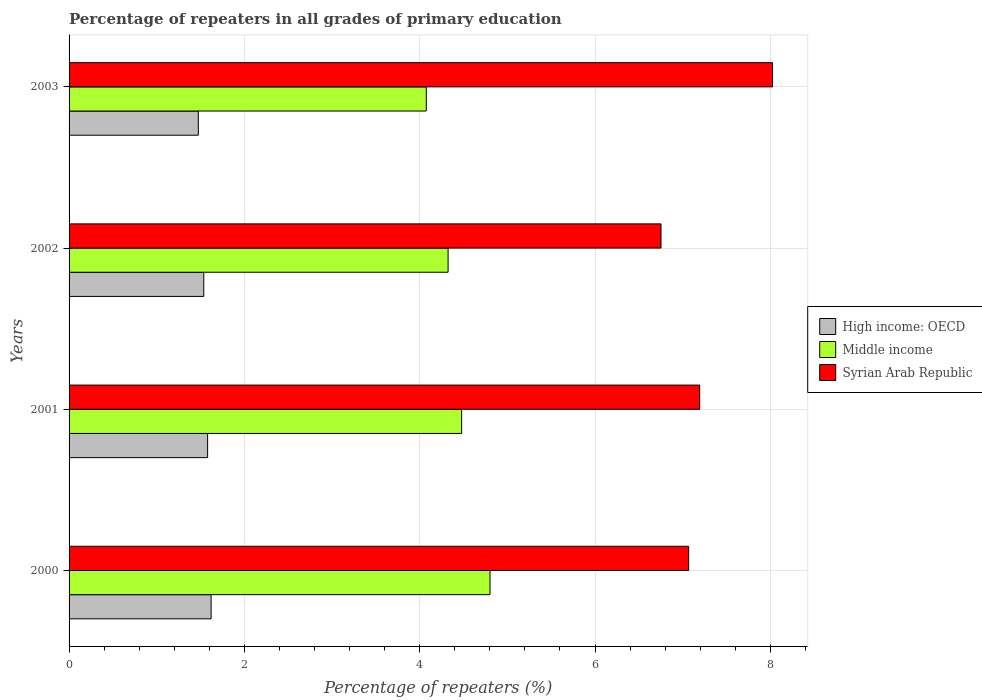How many different coloured bars are there?
Offer a terse response. 3. How many groups of bars are there?
Offer a very short reply. 4. Are the number of bars per tick equal to the number of legend labels?
Ensure brevity in your answer.  Yes. Are the number of bars on each tick of the Y-axis equal?
Offer a terse response. Yes. What is the percentage of repeaters in Syrian Arab Republic in 2001?
Make the answer very short. 7.19. Across all years, what is the maximum percentage of repeaters in Syrian Arab Republic?
Your answer should be compact. 8.02. Across all years, what is the minimum percentage of repeaters in High income: OECD?
Provide a succinct answer. 1.47. What is the total percentage of repeaters in Middle income in the graph?
Your answer should be compact. 17.68. What is the difference between the percentage of repeaters in High income: OECD in 2001 and that in 2003?
Provide a short and direct response. 0.11. What is the difference between the percentage of repeaters in Syrian Arab Republic in 2000 and the percentage of repeaters in Middle income in 2003?
Give a very brief answer. 2.99. What is the average percentage of repeaters in Middle income per year?
Your response must be concise. 4.42. In the year 2003, what is the difference between the percentage of repeaters in Middle income and percentage of repeaters in Syrian Arab Republic?
Ensure brevity in your answer.  -3.95. In how many years, is the percentage of repeaters in Syrian Arab Republic greater than 0.4 %?
Give a very brief answer. 4. What is the ratio of the percentage of repeaters in Middle income in 2001 to that in 2002?
Ensure brevity in your answer.  1.04. What is the difference between the highest and the second highest percentage of repeaters in Syrian Arab Republic?
Keep it short and to the point. 0.83. What is the difference between the highest and the lowest percentage of repeaters in Middle income?
Ensure brevity in your answer.  0.73. What does the 3rd bar from the bottom in 2000 represents?
Make the answer very short. Syrian Arab Republic. Is it the case that in every year, the sum of the percentage of repeaters in High income: OECD and percentage of repeaters in Syrian Arab Republic is greater than the percentage of repeaters in Middle income?
Your answer should be compact. Yes. How many bars are there?
Keep it short and to the point. 12. What is the difference between two consecutive major ticks on the X-axis?
Your answer should be compact. 2. Are the values on the major ticks of X-axis written in scientific E-notation?
Your answer should be very brief. No. Does the graph contain grids?
Offer a very short reply. Yes. How many legend labels are there?
Offer a terse response. 3. What is the title of the graph?
Keep it short and to the point. Percentage of repeaters in all grades of primary education. Does "Pacific island small states" appear as one of the legend labels in the graph?
Provide a succinct answer. No. What is the label or title of the X-axis?
Ensure brevity in your answer.  Percentage of repeaters (%). What is the Percentage of repeaters (%) of High income: OECD in 2000?
Provide a short and direct response. 1.62. What is the Percentage of repeaters (%) of Middle income in 2000?
Your answer should be compact. 4.8. What is the Percentage of repeaters (%) in Syrian Arab Republic in 2000?
Make the answer very short. 7.07. What is the Percentage of repeaters (%) of High income: OECD in 2001?
Ensure brevity in your answer.  1.58. What is the Percentage of repeaters (%) in Middle income in 2001?
Your answer should be compact. 4.48. What is the Percentage of repeaters (%) of Syrian Arab Republic in 2001?
Your response must be concise. 7.19. What is the Percentage of repeaters (%) in High income: OECD in 2002?
Ensure brevity in your answer.  1.54. What is the Percentage of repeaters (%) of Middle income in 2002?
Offer a terse response. 4.32. What is the Percentage of repeaters (%) of Syrian Arab Republic in 2002?
Your response must be concise. 6.75. What is the Percentage of repeaters (%) of High income: OECD in 2003?
Make the answer very short. 1.47. What is the Percentage of repeaters (%) in Middle income in 2003?
Your answer should be very brief. 4.08. What is the Percentage of repeaters (%) of Syrian Arab Republic in 2003?
Give a very brief answer. 8.02. Across all years, what is the maximum Percentage of repeaters (%) in High income: OECD?
Make the answer very short. 1.62. Across all years, what is the maximum Percentage of repeaters (%) in Middle income?
Your answer should be very brief. 4.8. Across all years, what is the maximum Percentage of repeaters (%) in Syrian Arab Republic?
Keep it short and to the point. 8.02. Across all years, what is the minimum Percentage of repeaters (%) in High income: OECD?
Offer a very short reply. 1.47. Across all years, what is the minimum Percentage of repeaters (%) of Middle income?
Keep it short and to the point. 4.08. Across all years, what is the minimum Percentage of repeaters (%) in Syrian Arab Republic?
Provide a short and direct response. 6.75. What is the total Percentage of repeaters (%) in High income: OECD in the graph?
Your answer should be compact. 6.21. What is the total Percentage of repeaters (%) in Middle income in the graph?
Provide a succinct answer. 17.68. What is the total Percentage of repeaters (%) in Syrian Arab Republic in the graph?
Your response must be concise. 29.04. What is the difference between the Percentage of repeaters (%) in High income: OECD in 2000 and that in 2001?
Your answer should be very brief. 0.04. What is the difference between the Percentage of repeaters (%) in Middle income in 2000 and that in 2001?
Your response must be concise. 0.32. What is the difference between the Percentage of repeaters (%) in Syrian Arab Republic in 2000 and that in 2001?
Provide a succinct answer. -0.13. What is the difference between the Percentage of repeaters (%) in High income: OECD in 2000 and that in 2002?
Your answer should be compact. 0.08. What is the difference between the Percentage of repeaters (%) of Middle income in 2000 and that in 2002?
Keep it short and to the point. 0.48. What is the difference between the Percentage of repeaters (%) of Syrian Arab Republic in 2000 and that in 2002?
Ensure brevity in your answer.  0.32. What is the difference between the Percentage of repeaters (%) of High income: OECD in 2000 and that in 2003?
Offer a terse response. 0.15. What is the difference between the Percentage of repeaters (%) in Middle income in 2000 and that in 2003?
Your response must be concise. 0.73. What is the difference between the Percentage of repeaters (%) in Syrian Arab Republic in 2000 and that in 2003?
Your answer should be compact. -0.96. What is the difference between the Percentage of repeaters (%) in High income: OECD in 2001 and that in 2002?
Keep it short and to the point. 0.04. What is the difference between the Percentage of repeaters (%) of Middle income in 2001 and that in 2002?
Make the answer very short. 0.15. What is the difference between the Percentage of repeaters (%) of Syrian Arab Republic in 2001 and that in 2002?
Ensure brevity in your answer.  0.44. What is the difference between the Percentage of repeaters (%) of High income: OECD in 2001 and that in 2003?
Offer a terse response. 0.11. What is the difference between the Percentage of repeaters (%) in Middle income in 2001 and that in 2003?
Make the answer very short. 0.4. What is the difference between the Percentage of repeaters (%) of Syrian Arab Republic in 2001 and that in 2003?
Your answer should be compact. -0.83. What is the difference between the Percentage of repeaters (%) of High income: OECD in 2002 and that in 2003?
Your answer should be very brief. 0.06. What is the difference between the Percentage of repeaters (%) in Middle income in 2002 and that in 2003?
Your response must be concise. 0.25. What is the difference between the Percentage of repeaters (%) in Syrian Arab Republic in 2002 and that in 2003?
Offer a terse response. -1.27. What is the difference between the Percentage of repeaters (%) of High income: OECD in 2000 and the Percentage of repeaters (%) of Middle income in 2001?
Offer a terse response. -2.86. What is the difference between the Percentage of repeaters (%) of High income: OECD in 2000 and the Percentage of repeaters (%) of Syrian Arab Republic in 2001?
Keep it short and to the point. -5.57. What is the difference between the Percentage of repeaters (%) of Middle income in 2000 and the Percentage of repeaters (%) of Syrian Arab Republic in 2001?
Your answer should be very brief. -2.39. What is the difference between the Percentage of repeaters (%) in High income: OECD in 2000 and the Percentage of repeaters (%) in Middle income in 2002?
Provide a short and direct response. -2.7. What is the difference between the Percentage of repeaters (%) of High income: OECD in 2000 and the Percentage of repeaters (%) of Syrian Arab Republic in 2002?
Ensure brevity in your answer.  -5.13. What is the difference between the Percentage of repeaters (%) in Middle income in 2000 and the Percentage of repeaters (%) in Syrian Arab Republic in 2002?
Give a very brief answer. -1.95. What is the difference between the Percentage of repeaters (%) of High income: OECD in 2000 and the Percentage of repeaters (%) of Middle income in 2003?
Your answer should be compact. -2.45. What is the difference between the Percentage of repeaters (%) in High income: OECD in 2000 and the Percentage of repeaters (%) in Syrian Arab Republic in 2003?
Your response must be concise. -6.4. What is the difference between the Percentage of repeaters (%) of Middle income in 2000 and the Percentage of repeaters (%) of Syrian Arab Republic in 2003?
Your response must be concise. -3.22. What is the difference between the Percentage of repeaters (%) in High income: OECD in 2001 and the Percentage of repeaters (%) in Middle income in 2002?
Offer a terse response. -2.74. What is the difference between the Percentage of repeaters (%) of High income: OECD in 2001 and the Percentage of repeaters (%) of Syrian Arab Republic in 2002?
Make the answer very short. -5.17. What is the difference between the Percentage of repeaters (%) in Middle income in 2001 and the Percentage of repeaters (%) in Syrian Arab Republic in 2002?
Your answer should be compact. -2.27. What is the difference between the Percentage of repeaters (%) of High income: OECD in 2001 and the Percentage of repeaters (%) of Middle income in 2003?
Your answer should be compact. -2.49. What is the difference between the Percentage of repeaters (%) of High income: OECD in 2001 and the Percentage of repeaters (%) of Syrian Arab Republic in 2003?
Your answer should be very brief. -6.44. What is the difference between the Percentage of repeaters (%) of Middle income in 2001 and the Percentage of repeaters (%) of Syrian Arab Republic in 2003?
Your answer should be compact. -3.55. What is the difference between the Percentage of repeaters (%) in High income: OECD in 2002 and the Percentage of repeaters (%) in Middle income in 2003?
Keep it short and to the point. -2.54. What is the difference between the Percentage of repeaters (%) of High income: OECD in 2002 and the Percentage of repeaters (%) of Syrian Arab Republic in 2003?
Offer a very short reply. -6.49. What is the difference between the Percentage of repeaters (%) in Middle income in 2002 and the Percentage of repeaters (%) in Syrian Arab Republic in 2003?
Ensure brevity in your answer.  -3.7. What is the average Percentage of repeaters (%) in High income: OECD per year?
Provide a succinct answer. 1.55. What is the average Percentage of repeaters (%) of Middle income per year?
Give a very brief answer. 4.42. What is the average Percentage of repeaters (%) of Syrian Arab Republic per year?
Offer a terse response. 7.26. In the year 2000, what is the difference between the Percentage of repeaters (%) of High income: OECD and Percentage of repeaters (%) of Middle income?
Your answer should be very brief. -3.18. In the year 2000, what is the difference between the Percentage of repeaters (%) in High income: OECD and Percentage of repeaters (%) in Syrian Arab Republic?
Offer a terse response. -5.45. In the year 2000, what is the difference between the Percentage of repeaters (%) of Middle income and Percentage of repeaters (%) of Syrian Arab Republic?
Keep it short and to the point. -2.27. In the year 2001, what is the difference between the Percentage of repeaters (%) of High income: OECD and Percentage of repeaters (%) of Middle income?
Your answer should be very brief. -2.9. In the year 2001, what is the difference between the Percentage of repeaters (%) in High income: OECD and Percentage of repeaters (%) in Syrian Arab Republic?
Your answer should be compact. -5.61. In the year 2001, what is the difference between the Percentage of repeaters (%) of Middle income and Percentage of repeaters (%) of Syrian Arab Republic?
Offer a very short reply. -2.72. In the year 2002, what is the difference between the Percentage of repeaters (%) of High income: OECD and Percentage of repeaters (%) of Middle income?
Your answer should be very brief. -2.79. In the year 2002, what is the difference between the Percentage of repeaters (%) of High income: OECD and Percentage of repeaters (%) of Syrian Arab Republic?
Offer a terse response. -5.22. In the year 2002, what is the difference between the Percentage of repeaters (%) of Middle income and Percentage of repeaters (%) of Syrian Arab Republic?
Keep it short and to the point. -2.43. In the year 2003, what is the difference between the Percentage of repeaters (%) in High income: OECD and Percentage of repeaters (%) in Middle income?
Ensure brevity in your answer.  -2.6. In the year 2003, what is the difference between the Percentage of repeaters (%) in High income: OECD and Percentage of repeaters (%) in Syrian Arab Republic?
Give a very brief answer. -6.55. In the year 2003, what is the difference between the Percentage of repeaters (%) in Middle income and Percentage of repeaters (%) in Syrian Arab Republic?
Ensure brevity in your answer.  -3.95. What is the ratio of the Percentage of repeaters (%) in High income: OECD in 2000 to that in 2001?
Your answer should be very brief. 1.03. What is the ratio of the Percentage of repeaters (%) of Middle income in 2000 to that in 2001?
Keep it short and to the point. 1.07. What is the ratio of the Percentage of repeaters (%) in Syrian Arab Republic in 2000 to that in 2001?
Ensure brevity in your answer.  0.98. What is the ratio of the Percentage of repeaters (%) in High income: OECD in 2000 to that in 2002?
Offer a terse response. 1.05. What is the ratio of the Percentage of repeaters (%) of Middle income in 2000 to that in 2002?
Your answer should be very brief. 1.11. What is the ratio of the Percentage of repeaters (%) in Syrian Arab Republic in 2000 to that in 2002?
Give a very brief answer. 1.05. What is the ratio of the Percentage of repeaters (%) in High income: OECD in 2000 to that in 2003?
Keep it short and to the point. 1.1. What is the ratio of the Percentage of repeaters (%) in Middle income in 2000 to that in 2003?
Ensure brevity in your answer.  1.18. What is the ratio of the Percentage of repeaters (%) of Syrian Arab Republic in 2000 to that in 2003?
Make the answer very short. 0.88. What is the ratio of the Percentage of repeaters (%) of High income: OECD in 2001 to that in 2002?
Your answer should be very brief. 1.03. What is the ratio of the Percentage of repeaters (%) in Middle income in 2001 to that in 2002?
Keep it short and to the point. 1.04. What is the ratio of the Percentage of repeaters (%) of Syrian Arab Republic in 2001 to that in 2002?
Provide a succinct answer. 1.07. What is the ratio of the Percentage of repeaters (%) in High income: OECD in 2001 to that in 2003?
Keep it short and to the point. 1.07. What is the ratio of the Percentage of repeaters (%) in Middle income in 2001 to that in 2003?
Offer a very short reply. 1.1. What is the ratio of the Percentage of repeaters (%) in Syrian Arab Republic in 2001 to that in 2003?
Keep it short and to the point. 0.9. What is the ratio of the Percentage of repeaters (%) in High income: OECD in 2002 to that in 2003?
Offer a very short reply. 1.04. What is the ratio of the Percentage of repeaters (%) in Middle income in 2002 to that in 2003?
Make the answer very short. 1.06. What is the ratio of the Percentage of repeaters (%) of Syrian Arab Republic in 2002 to that in 2003?
Offer a terse response. 0.84. What is the difference between the highest and the second highest Percentage of repeaters (%) of High income: OECD?
Provide a short and direct response. 0.04. What is the difference between the highest and the second highest Percentage of repeaters (%) in Middle income?
Your answer should be very brief. 0.32. What is the difference between the highest and the second highest Percentage of repeaters (%) in Syrian Arab Republic?
Provide a succinct answer. 0.83. What is the difference between the highest and the lowest Percentage of repeaters (%) of High income: OECD?
Offer a terse response. 0.15. What is the difference between the highest and the lowest Percentage of repeaters (%) of Middle income?
Your response must be concise. 0.73. What is the difference between the highest and the lowest Percentage of repeaters (%) of Syrian Arab Republic?
Your response must be concise. 1.27. 